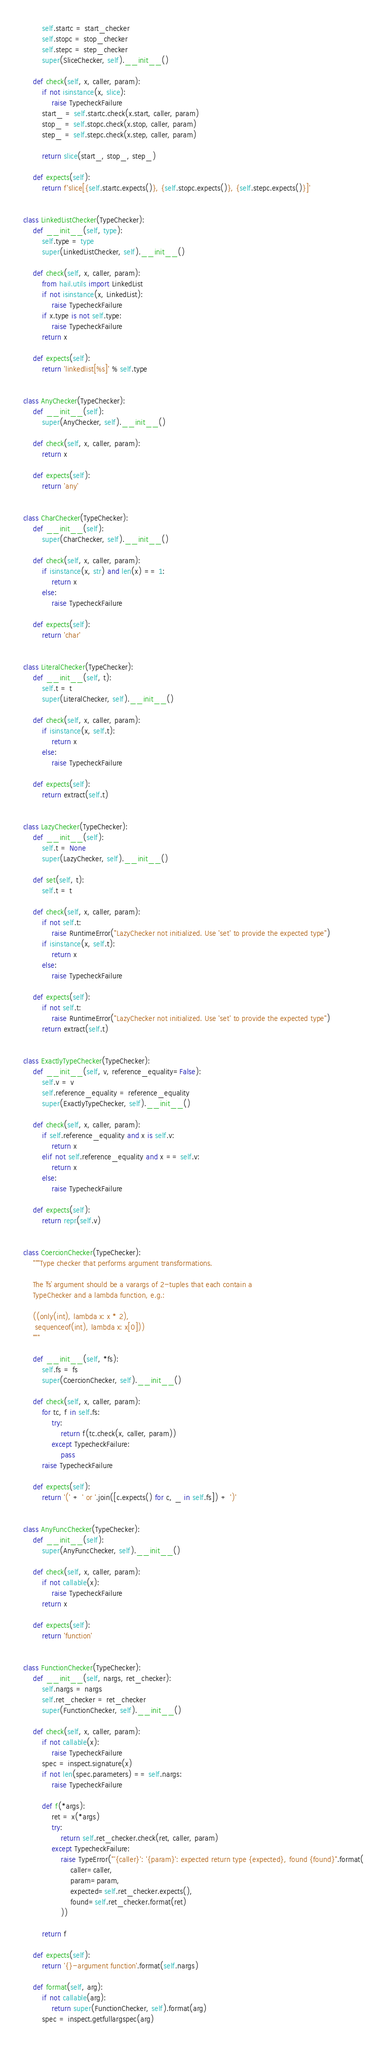Convert code to text. <code><loc_0><loc_0><loc_500><loc_500><_Python_>        self.startc = start_checker
        self.stopc = stop_checker
        self.stepc = step_checker
        super(SliceChecker, self).__init__()

    def check(self, x, caller, param):
        if not isinstance(x, slice):
            raise TypecheckFailure
        start_ = self.startc.check(x.start, caller, param)
        stop_ = self.stopc.check(x.stop, caller, param)
        step_ = self.stepc.check(x.step, caller, param)

        return slice(start_, stop_, step_)

    def expects(self):
        return f'slice[{self.startc.expects()}, {self.stopc.expects()}, {self.stepc.expects()}]'


class LinkedListChecker(TypeChecker):
    def __init__(self, type):
        self.type = type
        super(LinkedListChecker, self).__init__()

    def check(self, x, caller, param):
        from hail.utils import LinkedList
        if not isinstance(x, LinkedList):
            raise TypecheckFailure
        if x.type is not self.type:
            raise TypecheckFailure
        return x

    def expects(self):
        return 'linkedlist[%s]' % self.type


class AnyChecker(TypeChecker):
    def __init__(self):
        super(AnyChecker, self).__init__()

    def check(self, x, caller, param):
        return x

    def expects(self):
        return 'any'


class CharChecker(TypeChecker):
    def __init__(self):
        super(CharChecker, self).__init__()

    def check(self, x, caller, param):
        if isinstance(x, str) and len(x) == 1:
            return x
        else:
            raise TypecheckFailure

    def expects(self):
        return 'char'


class LiteralChecker(TypeChecker):
    def __init__(self, t):
        self.t = t
        super(LiteralChecker, self).__init__()

    def check(self, x, caller, param):
        if isinstance(x, self.t):
            return x
        else:
            raise TypecheckFailure

    def expects(self):
        return extract(self.t)


class LazyChecker(TypeChecker):
    def __init__(self):
        self.t = None
        super(LazyChecker, self).__init__()

    def set(self, t):
        self.t = t

    def check(self, x, caller, param):
        if not self.t:
            raise RuntimeError("LazyChecker not initialized. Use 'set' to provide the expected type")
        if isinstance(x, self.t):
            return x
        else:
            raise TypecheckFailure

    def expects(self):
        if not self.t:
            raise RuntimeError("LazyChecker not initialized. Use 'set' to provide the expected type")
        return extract(self.t)


class ExactlyTypeChecker(TypeChecker):
    def __init__(self, v, reference_equality=False):
        self.v = v
        self.reference_equality = reference_equality
        super(ExactlyTypeChecker, self).__init__()

    def check(self, x, caller, param):
        if self.reference_equality and x is self.v:
            return x
        elif not self.reference_equality and x == self.v:
            return x
        else:
            raise TypecheckFailure

    def expects(self):
        return repr(self.v)


class CoercionChecker(TypeChecker):
    """Type checker that performs argument transformations.

    The `fs` argument should be a varargs of 2-tuples that each contain a
    TypeChecker and a lambda function, e.g.:

    ((only(int), lambda x: x * 2),
     sequenceof(int), lambda x: x[0]))
    """

    def __init__(self, *fs):
        self.fs = fs
        super(CoercionChecker, self).__init__()

    def check(self, x, caller, param):
        for tc, f in self.fs:
            try:
                return f(tc.check(x, caller, param))
            except TypecheckFailure:
                pass
        raise TypecheckFailure

    def expects(self):
        return '(' + ' or '.join([c.expects() for c, _ in self.fs]) + ')'


class AnyFuncChecker(TypeChecker):
    def __init__(self):
        super(AnyFuncChecker, self).__init__()

    def check(self, x, caller, param):
        if not callable(x):
            raise TypecheckFailure
        return x

    def expects(self):
        return 'function'


class FunctionChecker(TypeChecker):
    def __init__(self, nargs, ret_checker):
        self.nargs = nargs
        self.ret_checker = ret_checker
        super(FunctionChecker, self).__init__()

    def check(self, x, caller, param):
        if not callable(x):
            raise TypecheckFailure
        spec = inspect.signature(x)
        if not len(spec.parameters) == self.nargs:
            raise TypecheckFailure

        def f(*args):
            ret = x(*args)
            try:
                return self.ret_checker.check(ret, caller, param)
            except TypecheckFailure:
                raise TypeError("'{caller}': '{param}': expected return type {expected}, found {found}".format(
                    caller=caller,
                    param=param,
                    expected=self.ret_checker.expects(),
                    found=self.ret_checker.format(ret)
                ))

        return f

    def expects(self):
        return '{}-argument function'.format(self.nargs)

    def format(self, arg):
        if not callable(arg):
            return super(FunctionChecker, self).format(arg)
        spec = inspect.getfullargspec(arg)</code> 